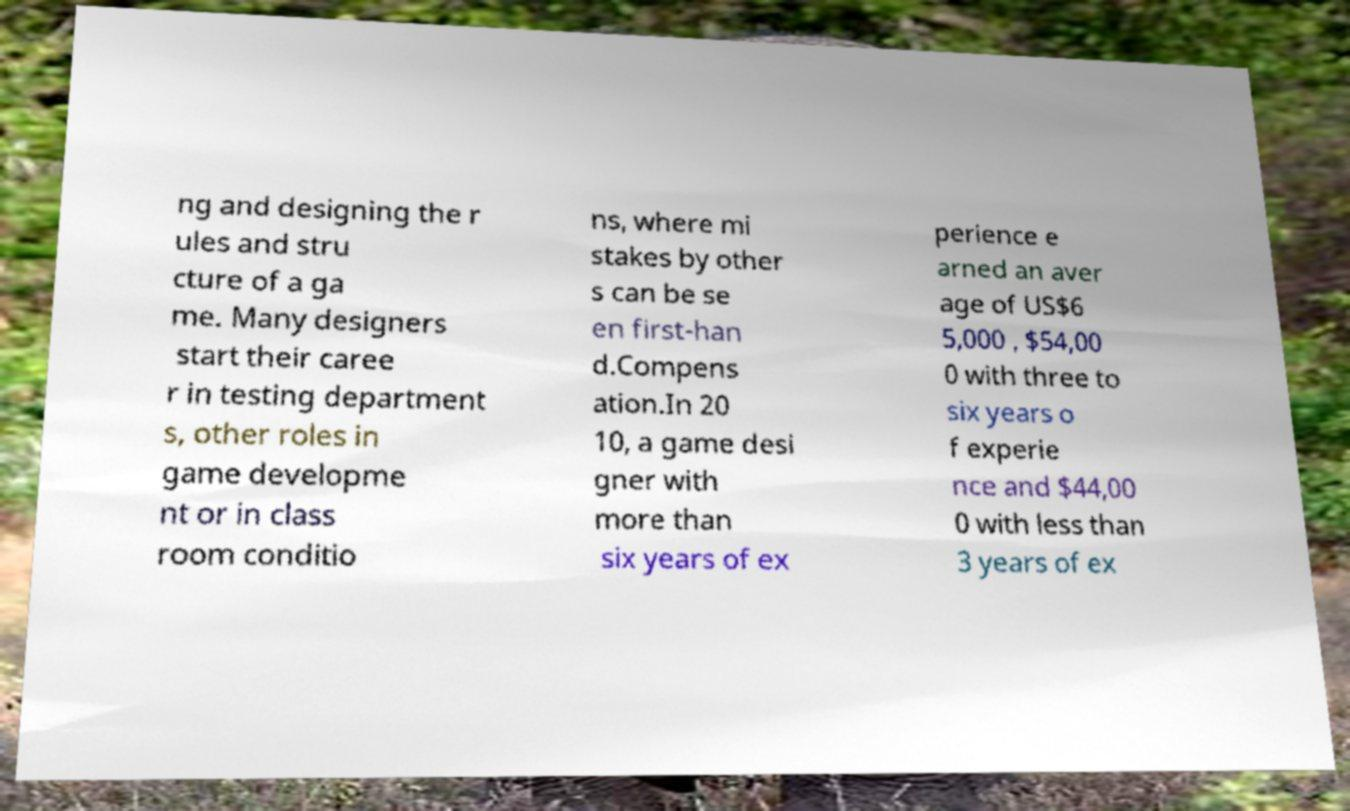Could you assist in decoding the text presented in this image and type it out clearly? ng and designing the r ules and stru cture of a ga me. Many designers start their caree r in testing department s, other roles in game developme nt or in class room conditio ns, where mi stakes by other s can be se en first-han d.Compens ation.In 20 10, a game desi gner with more than six years of ex perience e arned an aver age of US$6 5,000 , $54,00 0 with three to six years o f experie nce and $44,00 0 with less than 3 years of ex 